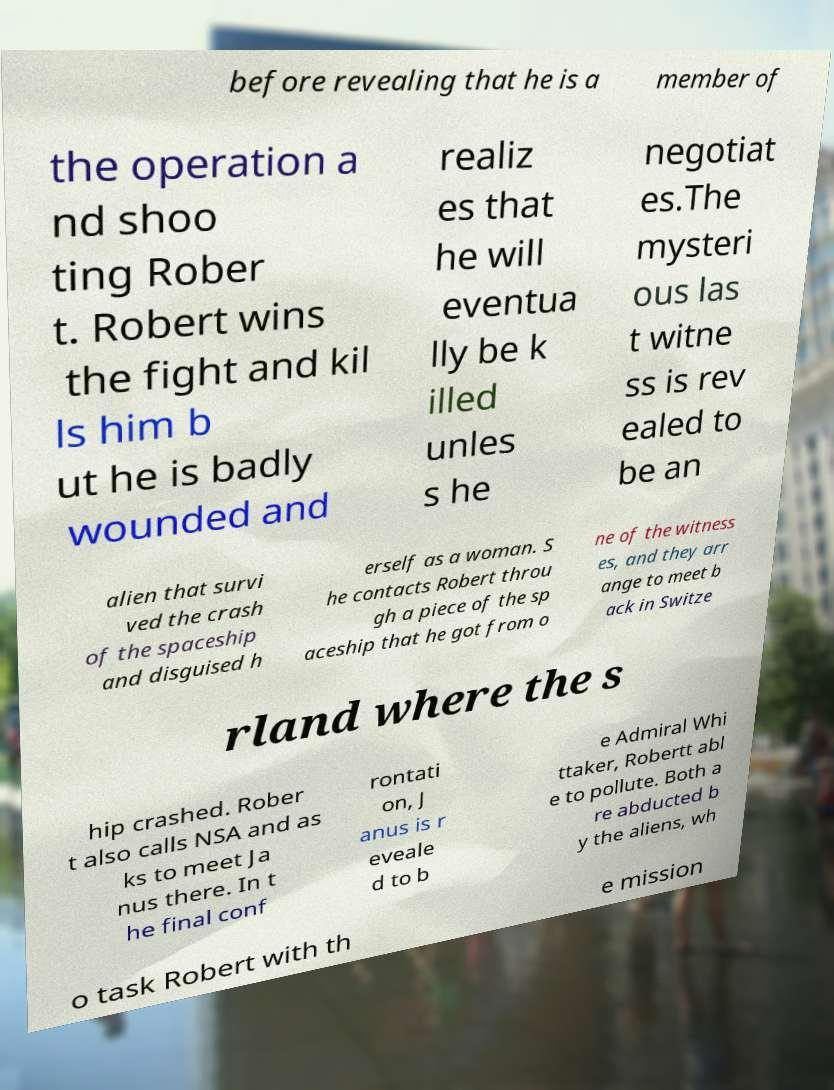Could you extract and type out the text from this image? before revealing that he is a member of the operation a nd shoo ting Rober t. Robert wins the fight and kil ls him b ut he is badly wounded and realiz es that he will eventua lly be k illed unles s he negotiat es.The mysteri ous las t witne ss is rev ealed to be an alien that survi ved the crash of the spaceship and disguised h erself as a woman. S he contacts Robert throu gh a piece of the sp aceship that he got from o ne of the witness es, and they arr ange to meet b ack in Switze rland where the s hip crashed. Rober t also calls NSA and as ks to meet Ja nus there. In t he final conf rontati on, J anus is r eveale d to b e Admiral Whi ttaker, Robertt abl e to pollute. Both a re abducted b y the aliens, wh o task Robert with th e mission 